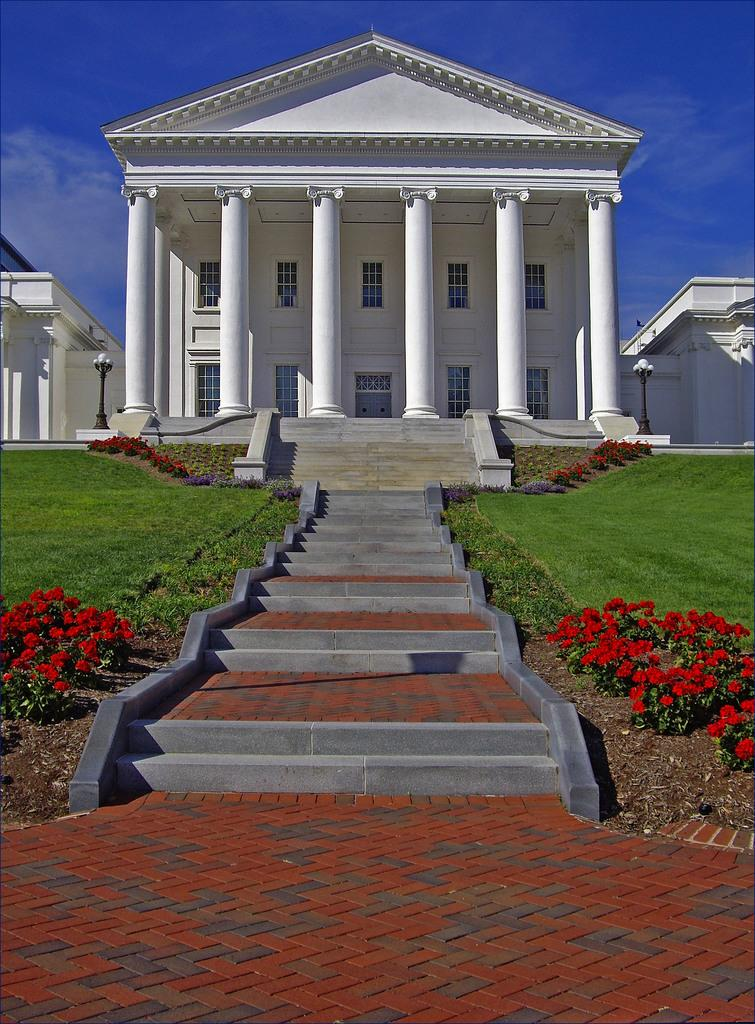What type of structure is visible in the image? There is a building in the image. What feature can be seen on the building? The building has windows. What type of clothing is present in the image? There are pants in the image. What architectural element is visible in the image? There are stairs in the image. What type of story is being told by the monkey in the image? There is no monkey present in the image, so no story is being told. How many light bulbs are visible in the image? There is no mention of light bulbs in the image, so we cannot determine the number of bulbs. 